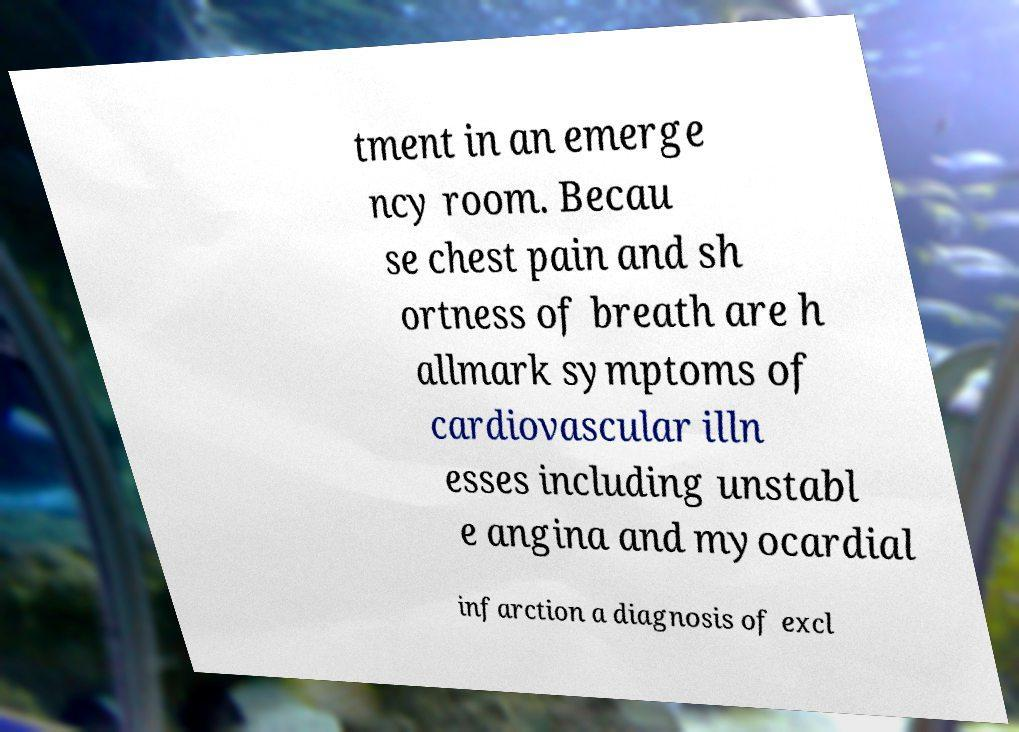Please read and relay the text visible in this image. What does it say? tment in an emerge ncy room. Becau se chest pain and sh ortness of breath are h allmark symptoms of cardiovascular illn esses including unstabl e angina and myocardial infarction a diagnosis of excl 